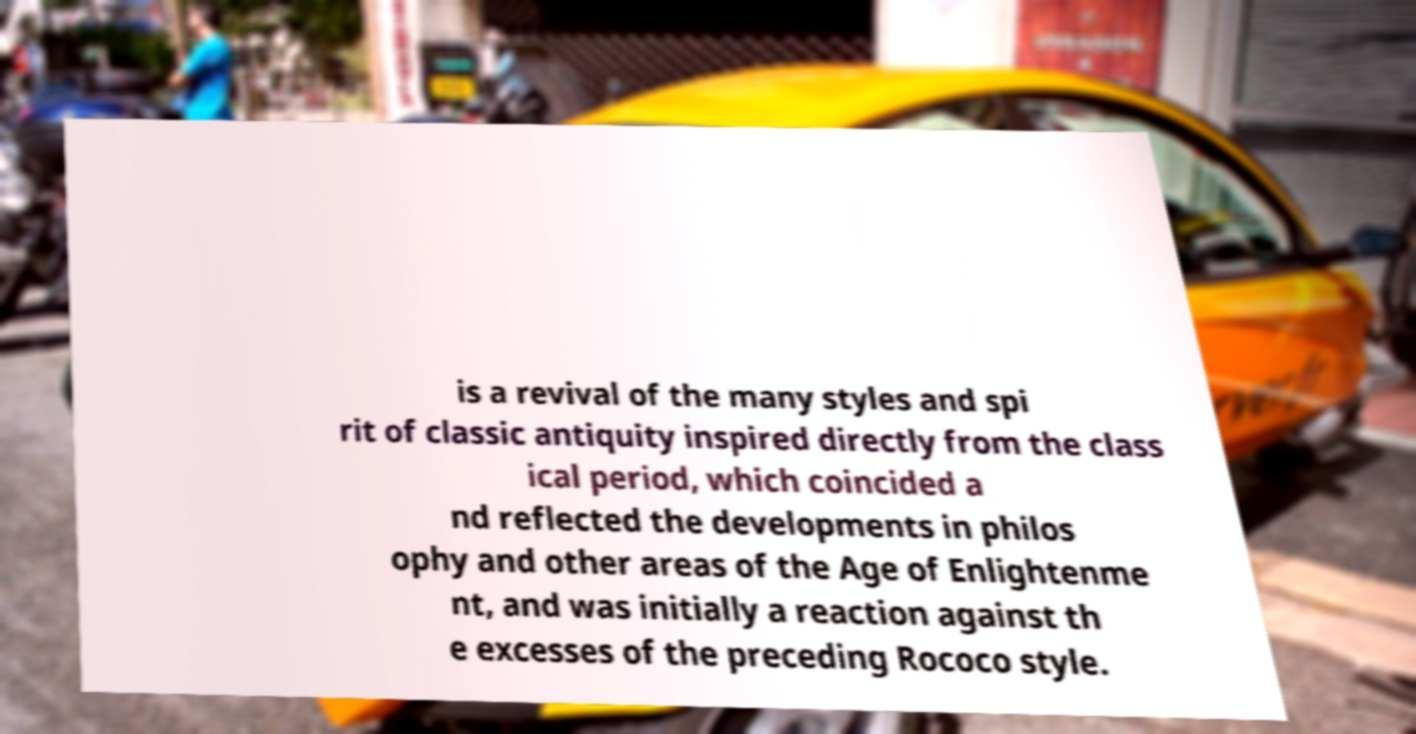I need the written content from this picture converted into text. Can you do that? is a revival of the many styles and spi rit of classic antiquity inspired directly from the class ical period, which coincided a nd reflected the developments in philos ophy and other areas of the Age of Enlightenme nt, and was initially a reaction against th e excesses of the preceding Rococo style. 